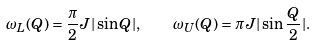<formula> <loc_0><loc_0><loc_500><loc_500>\omega _ { L } ( Q ) = \frac { \pi } { 2 } J | \sin Q | , \quad \omega _ { U } ( Q ) = \pi J | \sin \frac { Q } { 2 } | .</formula> 